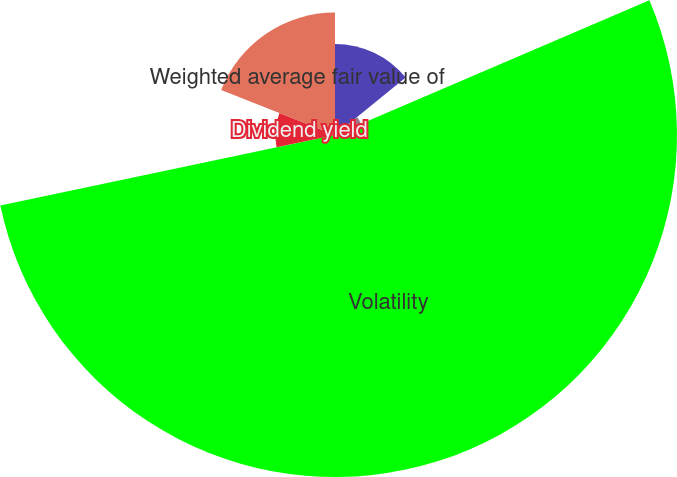<chart> <loc_0><loc_0><loc_500><loc_500><pie_chart><fcel>Expected life (in years)<fcel>Risk-free interest rate<fcel>Volatility<fcel>Dividend yield<fcel>Weighted average fair value of<nl><fcel>14.15%<fcel>4.41%<fcel>53.14%<fcel>9.28%<fcel>19.02%<nl></chart> 